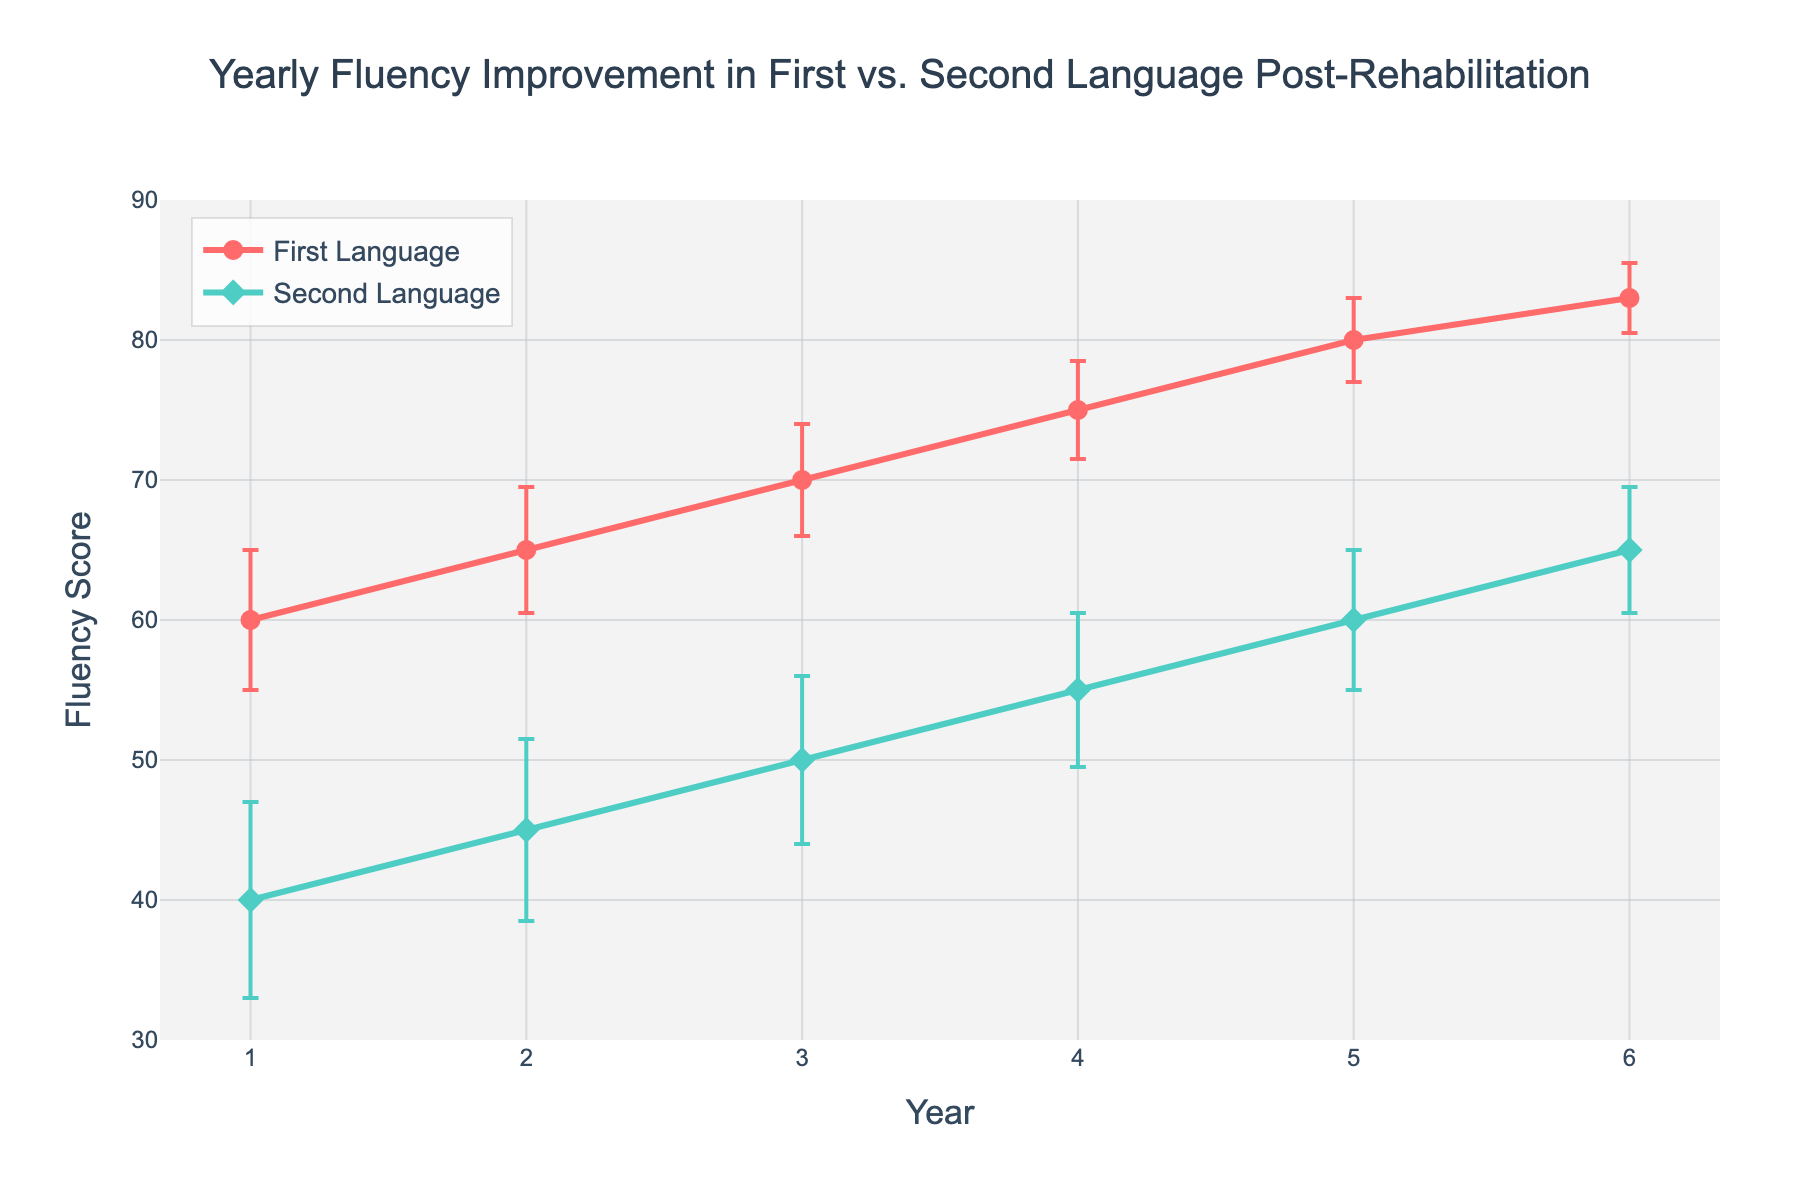What's the title of the plot? The title is displayed at the top center of the figure. It reads "Yearly Fluency Improvement in First vs. Second Language Post-Rehabilitation."
Answer: Yearly Fluency Improvement in First vs. Second Language Post-Rehabilitation What are the variables on the x and y axes? The x-axis represents "Year," while the y-axis represents "Fluency Score." These can be identified by the labels on the respective axes.
Answer: Year; Fluency Score What color represents the First Language in the plot? The First Language is represented by a red line, which can be identified by looking at the color and matching it to the legend.
Answer: Red How many years are covered in this study? The x-axis shows data points for each year, and the range is from Year 1 to Year 6. So, there are six data points.
Answer: 6 What's the fluency score for the First Language in Year 3? By finding the Year 3 point on the x-axis and looking at its corresponding value on the y-axis for the red line, we see the fluency score is 70.
Answer: 70 What is the fluency score for the Second Language in Year 5? Locate Year 5 on the x-axis and check the corresponding value for the teal-colored line. The fluency score is 60.
Answer: 60 How much did the fluency score for the Second Language improve from Year 1 to Year 6? The fluency score for the Second Language starts at 40 in Year 1 and rises to 65 in Year 6. The improvement is the difference, which is 65 - 40 = 25.
Answer: 25 Which language shows a higher fluency score consistently over the six years? By visually comparing the positions of the red and teal lines at each year, the red line (First Language) is consistently higher than the teal line (Second Language).
Answer: First Language What is the error range for the First Language's fluency score in Year 4? In Year 4, the fluency score is 75 with a standard deviation of 3.5. Thus, the error range is 75 ± 3.5, which is from 71.5 to 78.5.
Answer: 71.5 to 78.5 During which year are the error bars the smallest for the Second Language? By examining the error bars for the Second Language for each year, we see they are smallest in Year 6 with a standard deviation of 4.5.
Answer: Year 6 